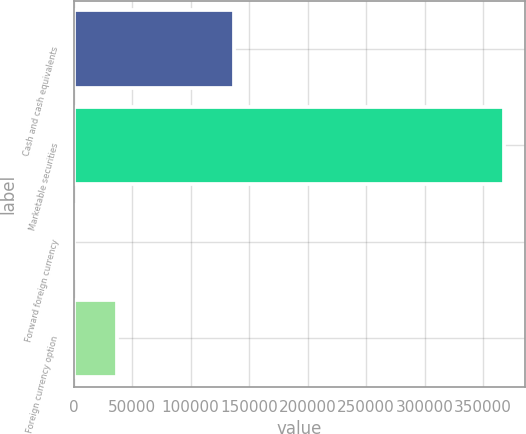Convert chart to OTSL. <chart><loc_0><loc_0><loc_500><loc_500><bar_chart><fcel>Cash and cash equivalents<fcel>Marketable securities<fcel>Forward foreign currency<fcel>Foreign currency option<nl><fcel>136781<fcel>367830<fcel>68<fcel>36844.2<nl></chart> 